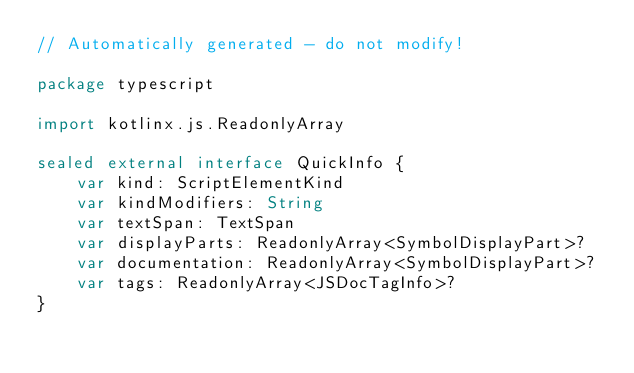<code> <loc_0><loc_0><loc_500><loc_500><_Kotlin_>// Automatically generated - do not modify!

package typescript

import kotlinx.js.ReadonlyArray

sealed external interface QuickInfo {
    var kind: ScriptElementKind
    var kindModifiers: String
    var textSpan: TextSpan
    var displayParts: ReadonlyArray<SymbolDisplayPart>?
    var documentation: ReadonlyArray<SymbolDisplayPart>?
    var tags: ReadonlyArray<JSDocTagInfo>?
}
</code> 